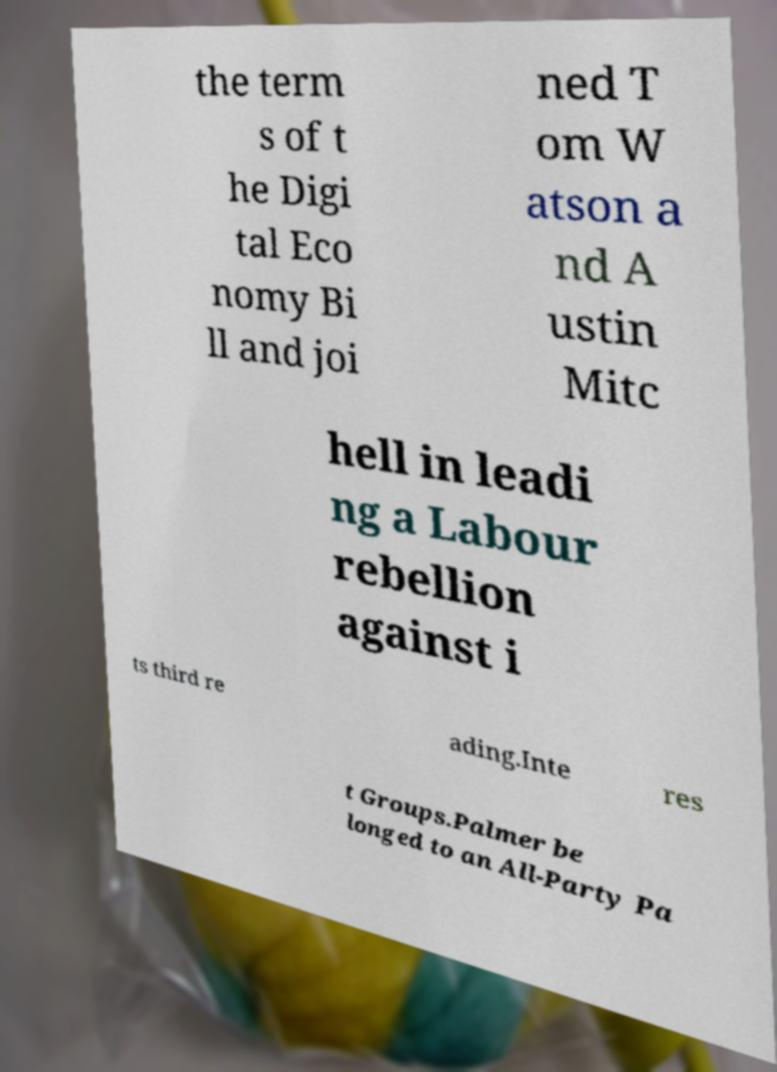For documentation purposes, I need the text within this image transcribed. Could you provide that? the term s of t he Digi tal Eco nomy Bi ll and joi ned T om W atson a nd A ustin Mitc hell in leadi ng a Labour rebellion against i ts third re ading.Inte res t Groups.Palmer be longed to an All-Party Pa 